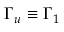<formula> <loc_0><loc_0><loc_500><loc_500>\Gamma _ { u } \equiv \Gamma _ { 1 }</formula> 